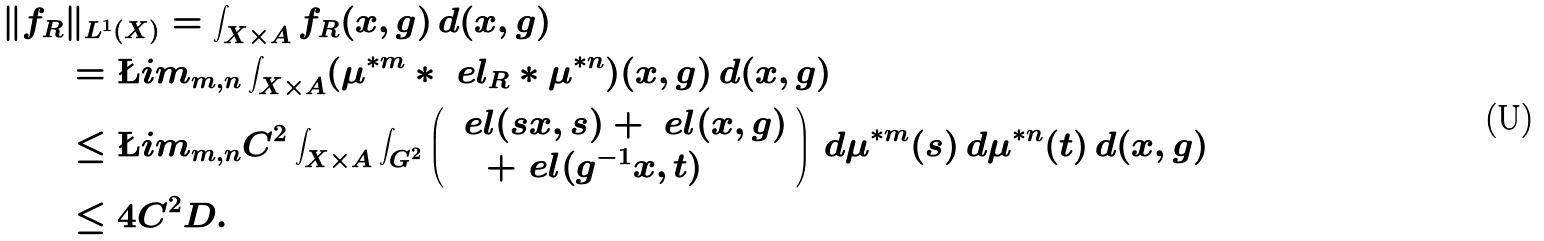Convert formula to latex. <formula><loc_0><loc_0><loc_500><loc_500>\| f _ { R } & \| _ { L ^ { 1 } ( X ) } = \int _ { X \times A } f _ { R } ( x , g ) \, d ( x , g ) \\ & = \L i m _ { m , n } \int _ { X \times A } ( \mu ^ { * m } * \ e l _ { R } * \mu ^ { * n } ) ( x , g ) \, d ( x , g ) \\ & \leq \L i m _ { m , n } C ^ { 2 } \int _ { X \times A } \int _ { G ^ { 2 } } \left ( \begin{array} { l } \ e l ( s x , s ) + \ e l ( x , g ) \\ \quad + \ e l ( g ^ { - 1 } x , t ) \end{array} \right ) \, d \mu ^ { * m } ( s ) \, d \mu ^ { * n } ( t ) \, d ( x , g ) \\ & \leq 4 C ^ { 2 } D .</formula> 